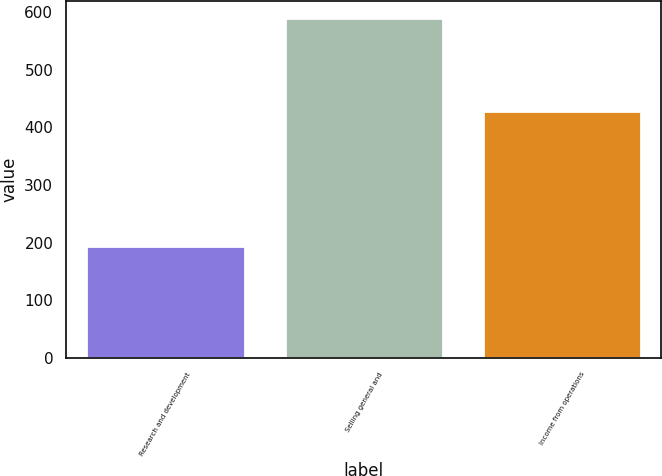<chart> <loc_0><loc_0><loc_500><loc_500><bar_chart><fcel>Research and development<fcel>Selling general and<fcel>Income from operations<nl><fcel>195<fcel>590<fcel>429<nl></chart> 